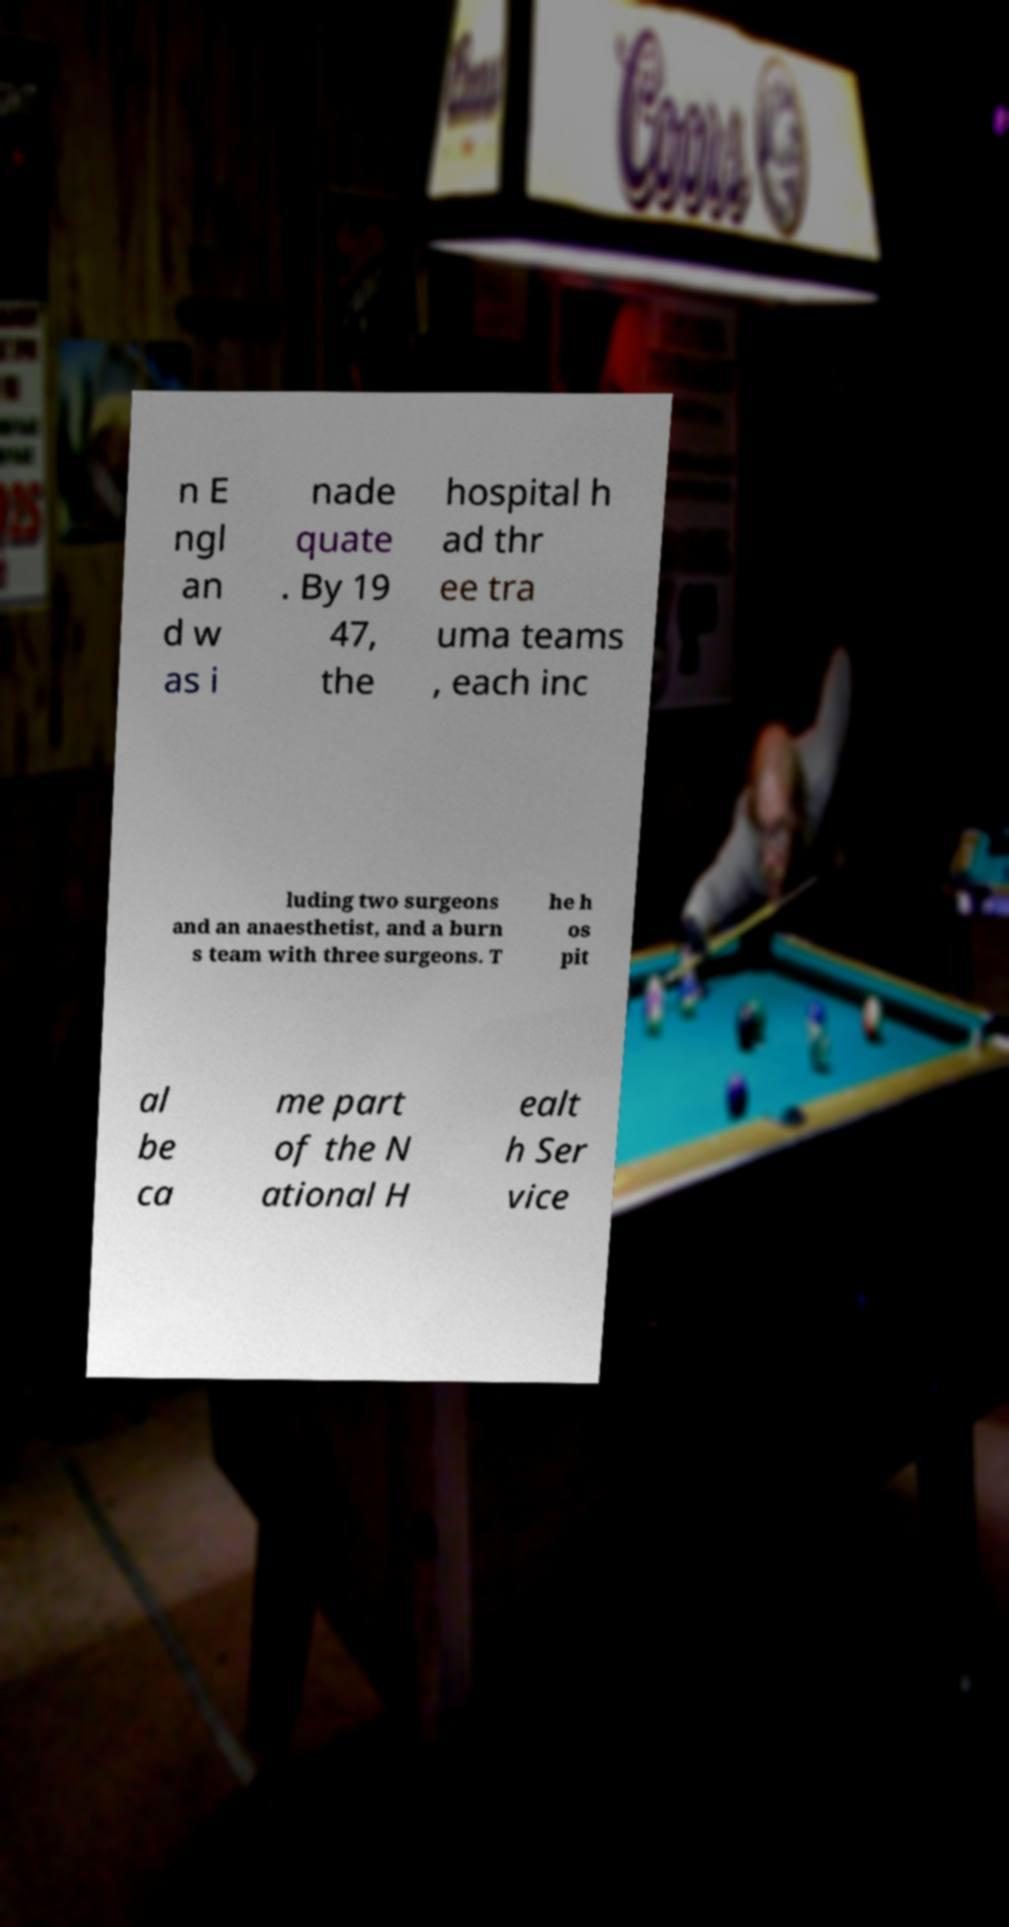Can you read and provide the text displayed in the image?This photo seems to have some interesting text. Can you extract and type it out for me? n E ngl an d w as i nade quate . By 19 47, the hospital h ad thr ee tra uma teams , each inc luding two surgeons and an anaesthetist, and a burn s team with three surgeons. T he h os pit al be ca me part of the N ational H ealt h Ser vice 